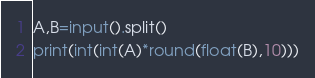<code> <loc_0><loc_0><loc_500><loc_500><_Python_>A,B=input().split()
print(int(int(A)*round(float(B),10)))
</code> 